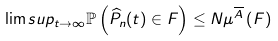Convert formula to latex. <formula><loc_0><loc_0><loc_500><loc_500>\lim s u p _ { t \rightarrow \infty } \mathbb { P } \left ( \widehat { P } _ { n } ( t ) \in F \right ) \leq N \mathbb { \mu } ^ { \overline { A } } \left ( F \right )</formula> 